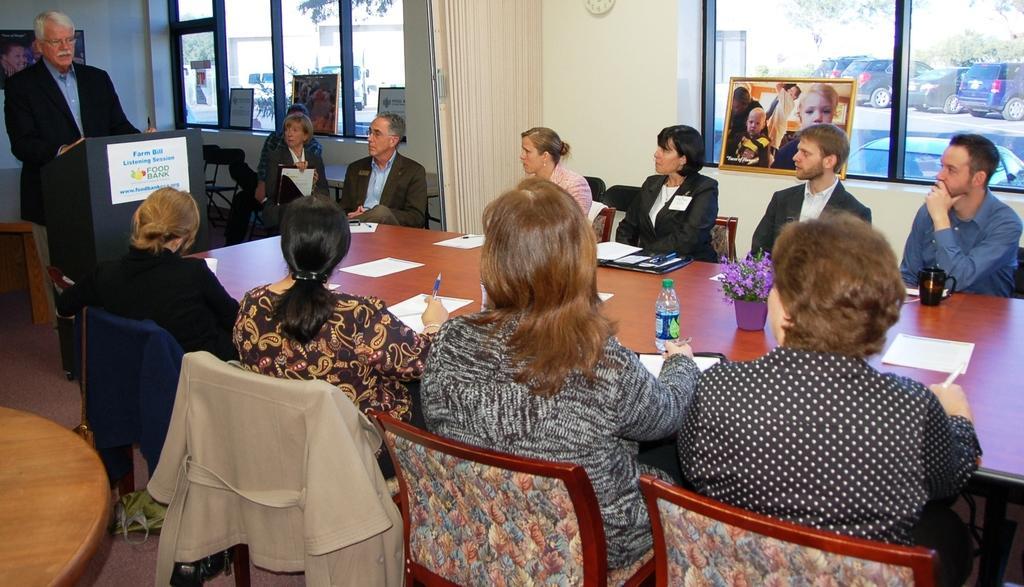How would you summarize this image in a sentence or two? As we can see in the image there is a cream color wall, clock, windows, outside the windows there are cars and trees, photo frame, few people standing and sitting here and there and there are chairs and tables. On tables there are bottles, files and papers. The man who is standing on the left side is talking. 